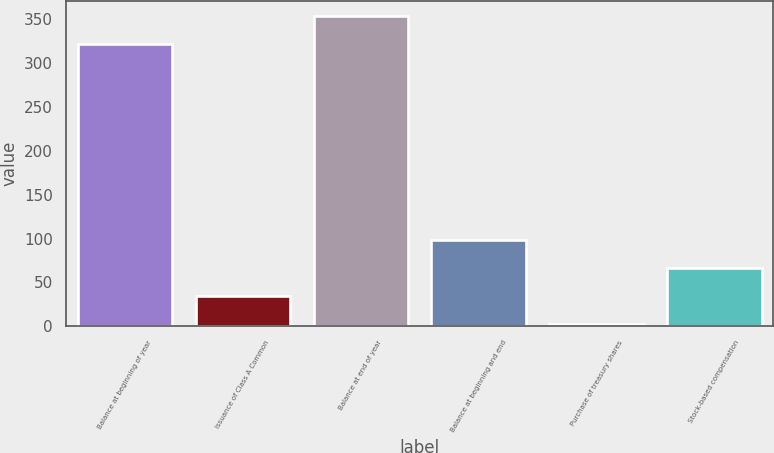<chart> <loc_0><loc_0><loc_500><loc_500><bar_chart><fcel>Balance at beginning of year<fcel>Issuance of Class A Common<fcel>Balance at end of year<fcel>Balance at beginning and end<fcel>Purchase of treasury shares<fcel>Stock-based compensation<nl><fcel>322<fcel>34.9<fcel>353.9<fcel>98.7<fcel>3<fcel>66.8<nl></chart> 